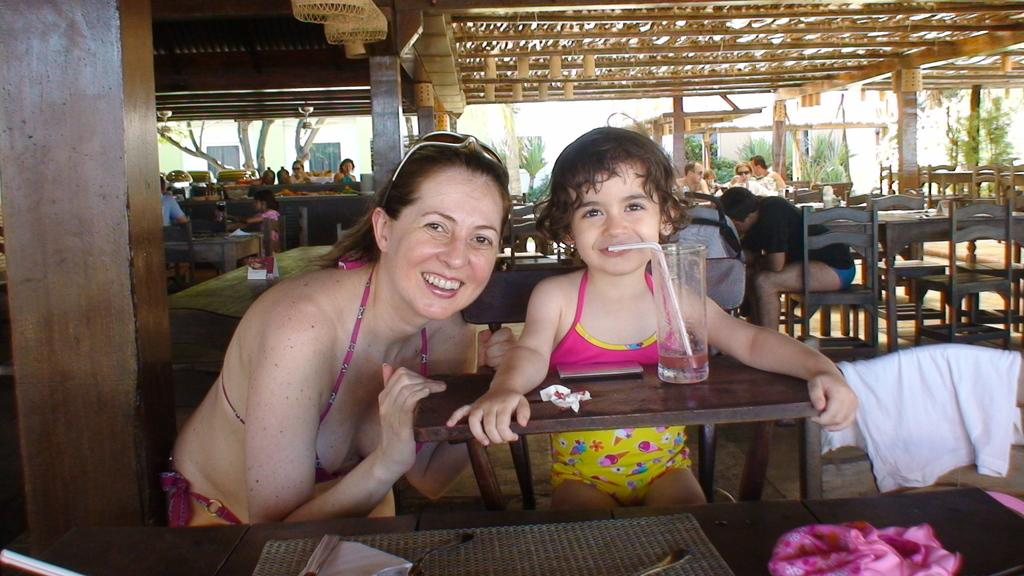Who are the people in the image? There is a woman and a girl in the image. What are the woman and the girl doing in the image? Both the woman and the girl are seated on a chair. What can be seen on the table in the image? There is a glass with a straw in the image. Can you describe the setting in the background of the image? There are people seated in the background. What type of silk is draped over the bikes in the field in the image? There are no bikes or fields present in the image; it features a woman and a girl seated on a chair with a glass and straw on a table. 